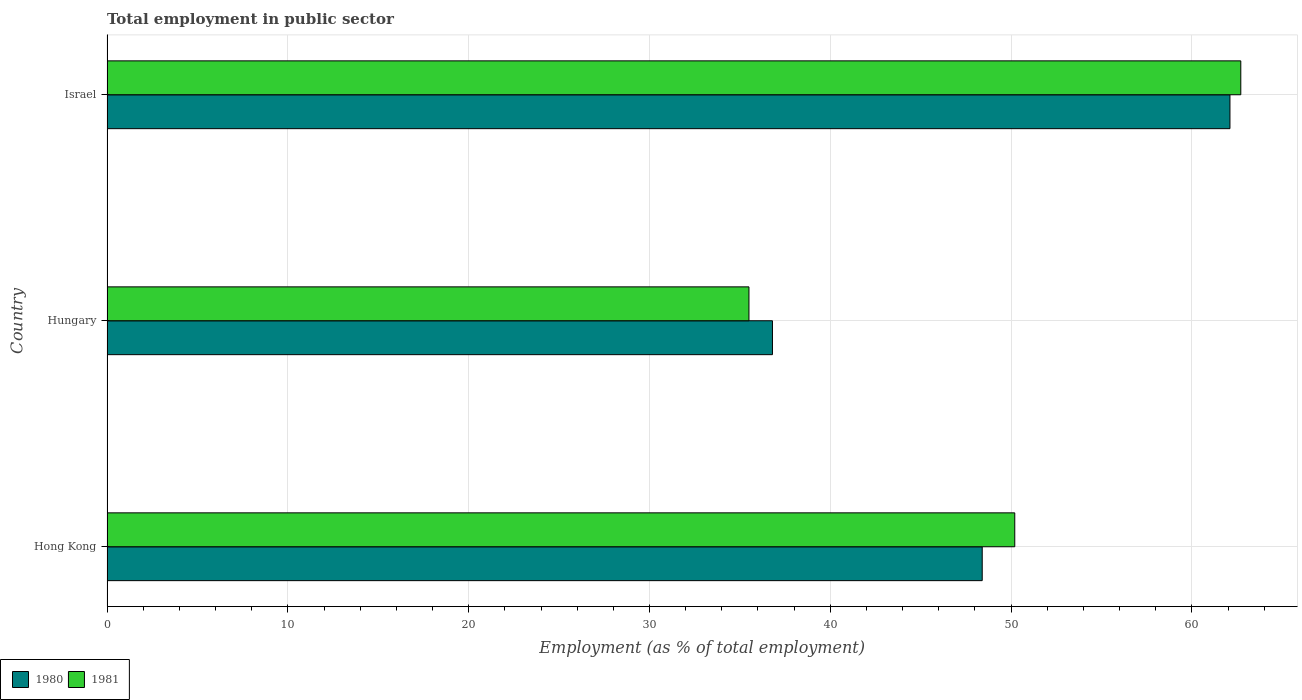Are the number of bars on each tick of the Y-axis equal?
Provide a short and direct response. Yes. How many bars are there on the 2nd tick from the bottom?
Your answer should be compact. 2. What is the label of the 1st group of bars from the top?
Offer a terse response. Israel. What is the employment in public sector in 1980 in Israel?
Make the answer very short. 62.1. Across all countries, what is the maximum employment in public sector in 1981?
Offer a terse response. 62.7. Across all countries, what is the minimum employment in public sector in 1980?
Your answer should be very brief. 36.8. In which country was the employment in public sector in 1980 maximum?
Your answer should be compact. Israel. In which country was the employment in public sector in 1980 minimum?
Ensure brevity in your answer.  Hungary. What is the total employment in public sector in 1980 in the graph?
Your answer should be compact. 147.3. What is the difference between the employment in public sector in 1980 in Hong Kong and that in Hungary?
Keep it short and to the point. 11.6. What is the difference between the employment in public sector in 1981 in Hong Kong and the employment in public sector in 1980 in Israel?
Provide a short and direct response. -11.9. What is the average employment in public sector in 1981 per country?
Ensure brevity in your answer.  49.47. What is the difference between the employment in public sector in 1981 and employment in public sector in 1980 in Hungary?
Your response must be concise. -1.3. What is the ratio of the employment in public sector in 1980 in Hungary to that in Israel?
Give a very brief answer. 0.59. Is the difference between the employment in public sector in 1981 in Hong Kong and Hungary greater than the difference between the employment in public sector in 1980 in Hong Kong and Hungary?
Provide a succinct answer. Yes. What is the difference between the highest and the lowest employment in public sector in 1981?
Make the answer very short. 27.2. In how many countries, is the employment in public sector in 1981 greater than the average employment in public sector in 1981 taken over all countries?
Make the answer very short. 2. How many bars are there?
Provide a succinct answer. 6. Are all the bars in the graph horizontal?
Your response must be concise. Yes. Are the values on the major ticks of X-axis written in scientific E-notation?
Your answer should be compact. No. Does the graph contain grids?
Keep it short and to the point. Yes. What is the title of the graph?
Keep it short and to the point. Total employment in public sector. What is the label or title of the X-axis?
Offer a very short reply. Employment (as % of total employment). What is the label or title of the Y-axis?
Your response must be concise. Country. What is the Employment (as % of total employment) of 1980 in Hong Kong?
Offer a very short reply. 48.4. What is the Employment (as % of total employment) in 1981 in Hong Kong?
Keep it short and to the point. 50.2. What is the Employment (as % of total employment) in 1980 in Hungary?
Give a very brief answer. 36.8. What is the Employment (as % of total employment) in 1981 in Hungary?
Make the answer very short. 35.5. What is the Employment (as % of total employment) in 1980 in Israel?
Make the answer very short. 62.1. What is the Employment (as % of total employment) in 1981 in Israel?
Give a very brief answer. 62.7. Across all countries, what is the maximum Employment (as % of total employment) of 1980?
Your answer should be compact. 62.1. Across all countries, what is the maximum Employment (as % of total employment) of 1981?
Your answer should be very brief. 62.7. Across all countries, what is the minimum Employment (as % of total employment) of 1980?
Your response must be concise. 36.8. Across all countries, what is the minimum Employment (as % of total employment) of 1981?
Ensure brevity in your answer.  35.5. What is the total Employment (as % of total employment) in 1980 in the graph?
Ensure brevity in your answer.  147.3. What is the total Employment (as % of total employment) in 1981 in the graph?
Ensure brevity in your answer.  148.4. What is the difference between the Employment (as % of total employment) in 1981 in Hong Kong and that in Hungary?
Give a very brief answer. 14.7. What is the difference between the Employment (as % of total employment) of 1980 in Hong Kong and that in Israel?
Offer a terse response. -13.7. What is the difference between the Employment (as % of total employment) of 1981 in Hong Kong and that in Israel?
Offer a terse response. -12.5. What is the difference between the Employment (as % of total employment) of 1980 in Hungary and that in Israel?
Provide a short and direct response. -25.3. What is the difference between the Employment (as % of total employment) of 1981 in Hungary and that in Israel?
Your response must be concise. -27.2. What is the difference between the Employment (as % of total employment) of 1980 in Hong Kong and the Employment (as % of total employment) of 1981 in Israel?
Your answer should be very brief. -14.3. What is the difference between the Employment (as % of total employment) in 1980 in Hungary and the Employment (as % of total employment) in 1981 in Israel?
Your answer should be compact. -25.9. What is the average Employment (as % of total employment) of 1980 per country?
Your answer should be very brief. 49.1. What is the average Employment (as % of total employment) in 1981 per country?
Give a very brief answer. 49.47. What is the difference between the Employment (as % of total employment) in 1980 and Employment (as % of total employment) in 1981 in Hong Kong?
Offer a terse response. -1.8. What is the difference between the Employment (as % of total employment) in 1980 and Employment (as % of total employment) in 1981 in Hungary?
Make the answer very short. 1.3. What is the difference between the Employment (as % of total employment) in 1980 and Employment (as % of total employment) in 1981 in Israel?
Provide a short and direct response. -0.6. What is the ratio of the Employment (as % of total employment) of 1980 in Hong Kong to that in Hungary?
Your answer should be compact. 1.32. What is the ratio of the Employment (as % of total employment) of 1981 in Hong Kong to that in Hungary?
Your response must be concise. 1.41. What is the ratio of the Employment (as % of total employment) of 1980 in Hong Kong to that in Israel?
Your answer should be compact. 0.78. What is the ratio of the Employment (as % of total employment) in 1981 in Hong Kong to that in Israel?
Your answer should be compact. 0.8. What is the ratio of the Employment (as % of total employment) in 1980 in Hungary to that in Israel?
Your answer should be compact. 0.59. What is the ratio of the Employment (as % of total employment) of 1981 in Hungary to that in Israel?
Offer a terse response. 0.57. What is the difference between the highest and the second highest Employment (as % of total employment) in 1981?
Ensure brevity in your answer.  12.5. What is the difference between the highest and the lowest Employment (as % of total employment) of 1980?
Offer a terse response. 25.3. What is the difference between the highest and the lowest Employment (as % of total employment) of 1981?
Offer a very short reply. 27.2. 